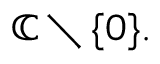<formula> <loc_0><loc_0><loc_500><loc_500>\mathbb { C } \ \{ 0 \} .</formula> 